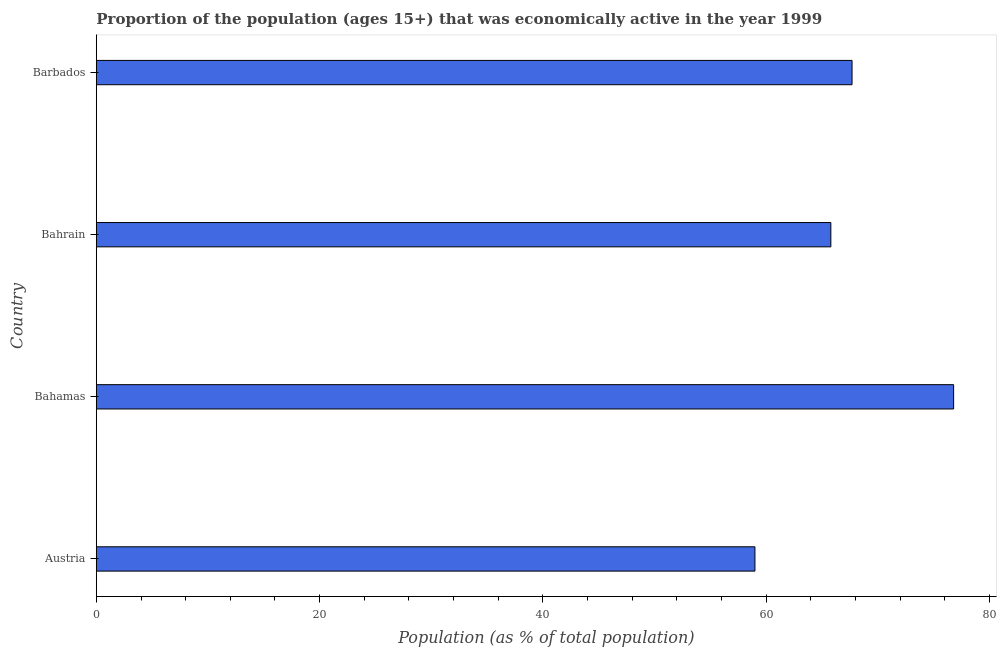Does the graph contain any zero values?
Your answer should be very brief. No. Does the graph contain grids?
Provide a short and direct response. No. What is the title of the graph?
Offer a terse response. Proportion of the population (ages 15+) that was economically active in the year 1999. What is the label or title of the X-axis?
Ensure brevity in your answer.  Population (as % of total population). What is the label or title of the Y-axis?
Ensure brevity in your answer.  Country. What is the percentage of economically active population in Bahrain?
Make the answer very short. 65.8. Across all countries, what is the maximum percentage of economically active population?
Ensure brevity in your answer.  76.8. In which country was the percentage of economically active population maximum?
Ensure brevity in your answer.  Bahamas. In which country was the percentage of economically active population minimum?
Your response must be concise. Austria. What is the sum of the percentage of economically active population?
Provide a succinct answer. 269.3. What is the average percentage of economically active population per country?
Your answer should be compact. 67.33. What is the median percentage of economically active population?
Provide a short and direct response. 66.75. In how many countries, is the percentage of economically active population greater than 28 %?
Your answer should be very brief. 4. What is the ratio of the percentage of economically active population in Bahamas to that in Barbados?
Offer a very short reply. 1.13. Is the difference between the percentage of economically active population in Austria and Bahamas greater than the difference between any two countries?
Provide a short and direct response. Yes. Is the sum of the percentage of economically active population in Bahrain and Barbados greater than the maximum percentage of economically active population across all countries?
Your answer should be very brief. Yes. What is the difference between the highest and the lowest percentage of economically active population?
Your answer should be compact. 17.8. What is the difference between two consecutive major ticks on the X-axis?
Offer a very short reply. 20. Are the values on the major ticks of X-axis written in scientific E-notation?
Make the answer very short. No. What is the Population (as % of total population) of Austria?
Provide a succinct answer. 59. What is the Population (as % of total population) in Bahamas?
Ensure brevity in your answer.  76.8. What is the Population (as % of total population) of Bahrain?
Your answer should be very brief. 65.8. What is the Population (as % of total population) in Barbados?
Ensure brevity in your answer.  67.7. What is the difference between the Population (as % of total population) in Austria and Bahamas?
Your answer should be compact. -17.8. What is the difference between the Population (as % of total population) in Austria and Bahrain?
Ensure brevity in your answer.  -6.8. What is the difference between the Population (as % of total population) in Austria and Barbados?
Ensure brevity in your answer.  -8.7. What is the difference between the Population (as % of total population) in Bahamas and Bahrain?
Provide a short and direct response. 11. What is the difference between the Population (as % of total population) in Bahamas and Barbados?
Make the answer very short. 9.1. What is the difference between the Population (as % of total population) in Bahrain and Barbados?
Your answer should be compact. -1.9. What is the ratio of the Population (as % of total population) in Austria to that in Bahamas?
Provide a succinct answer. 0.77. What is the ratio of the Population (as % of total population) in Austria to that in Bahrain?
Offer a very short reply. 0.9. What is the ratio of the Population (as % of total population) in Austria to that in Barbados?
Provide a succinct answer. 0.87. What is the ratio of the Population (as % of total population) in Bahamas to that in Bahrain?
Ensure brevity in your answer.  1.17. What is the ratio of the Population (as % of total population) in Bahamas to that in Barbados?
Your response must be concise. 1.13. What is the ratio of the Population (as % of total population) in Bahrain to that in Barbados?
Ensure brevity in your answer.  0.97. 